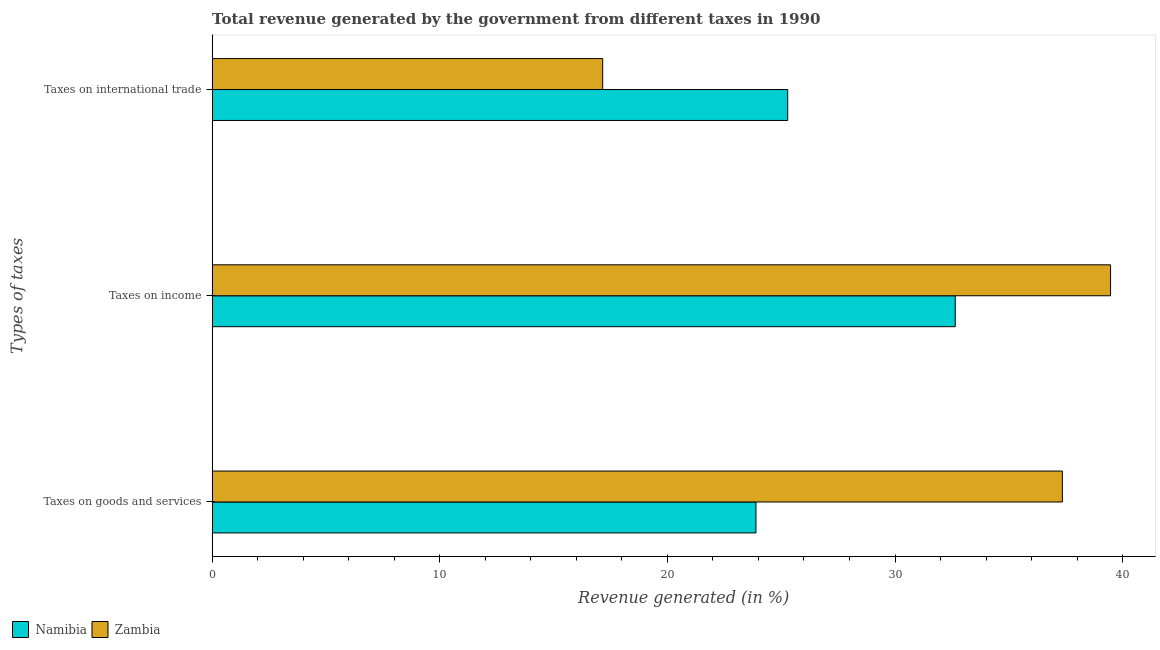How many different coloured bars are there?
Your answer should be compact. 2. What is the label of the 2nd group of bars from the top?
Give a very brief answer. Taxes on income. What is the percentage of revenue generated by tax on international trade in Zambia?
Offer a very short reply. 17.16. Across all countries, what is the maximum percentage of revenue generated by taxes on income?
Your answer should be very brief. 39.47. Across all countries, what is the minimum percentage of revenue generated by tax on international trade?
Provide a succinct answer. 17.16. In which country was the percentage of revenue generated by tax on international trade maximum?
Keep it short and to the point. Namibia. In which country was the percentage of revenue generated by taxes on income minimum?
Provide a short and direct response. Namibia. What is the total percentage of revenue generated by taxes on goods and services in the graph?
Make the answer very short. 61.24. What is the difference between the percentage of revenue generated by taxes on income in Zambia and that in Namibia?
Offer a very short reply. 6.82. What is the difference between the percentage of revenue generated by taxes on goods and services in Zambia and the percentage of revenue generated by taxes on income in Namibia?
Your answer should be compact. 4.71. What is the average percentage of revenue generated by taxes on goods and services per country?
Your answer should be compact. 30.62. What is the difference between the percentage of revenue generated by tax on international trade and percentage of revenue generated by taxes on income in Namibia?
Offer a very short reply. -7.36. In how many countries, is the percentage of revenue generated by tax on international trade greater than 20 %?
Provide a short and direct response. 1. What is the ratio of the percentage of revenue generated by tax on international trade in Namibia to that in Zambia?
Provide a short and direct response. 1.47. Is the percentage of revenue generated by tax on international trade in Zambia less than that in Namibia?
Ensure brevity in your answer.  Yes. Is the difference between the percentage of revenue generated by taxes on goods and services in Zambia and Namibia greater than the difference between the percentage of revenue generated by tax on international trade in Zambia and Namibia?
Provide a succinct answer. Yes. What is the difference between the highest and the second highest percentage of revenue generated by taxes on goods and services?
Provide a short and direct response. 13.46. What is the difference between the highest and the lowest percentage of revenue generated by tax on international trade?
Offer a terse response. 8.13. Is the sum of the percentage of revenue generated by taxes on goods and services in Namibia and Zambia greater than the maximum percentage of revenue generated by tax on international trade across all countries?
Give a very brief answer. Yes. What does the 1st bar from the top in Taxes on international trade represents?
Ensure brevity in your answer.  Zambia. What does the 2nd bar from the bottom in Taxes on goods and services represents?
Ensure brevity in your answer.  Zambia. How many bars are there?
Your answer should be compact. 6. How many countries are there in the graph?
Offer a terse response. 2. What is the difference between two consecutive major ticks on the X-axis?
Your response must be concise. 10. Does the graph contain grids?
Offer a terse response. No. Where does the legend appear in the graph?
Offer a terse response. Bottom left. How many legend labels are there?
Your answer should be compact. 2. How are the legend labels stacked?
Keep it short and to the point. Horizontal. What is the title of the graph?
Give a very brief answer. Total revenue generated by the government from different taxes in 1990. What is the label or title of the X-axis?
Offer a terse response. Revenue generated (in %). What is the label or title of the Y-axis?
Offer a terse response. Types of taxes. What is the Revenue generated (in %) of Namibia in Taxes on goods and services?
Keep it short and to the point. 23.89. What is the Revenue generated (in %) in Zambia in Taxes on goods and services?
Your response must be concise. 37.35. What is the Revenue generated (in %) of Namibia in Taxes on income?
Offer a terse response. 32.64. What is the Revenue generated (in %) in Zambia in Taxes on income?
Your answer should be very brief. 39.47. What is the Revenue generated (in %) of Namibia in Taxes on international trade?
Keep it short and to the point. 25.29. What is the Revenue generated (in %) in Zambia in Taxes on international trade?
Provide a succinct answer. 17.16. Across all Types of taxes, what is the maximum Revenue generated (in %) of Namibia?
Make the answer very short. 32.64. Across all Types of taxes, what is the maximum Revenue generated (in %) in Zambia?
Offer a very short reply. 39.47. Across all Types of taxes, what is the minimum Revenue generated (in %) in Namibia?
Your answer should be very brief. 23.89. Across all Types of taxes, what is the minimum Revenue generated (in %) of Zambia?
Provide a short and direct response. 17.16. What is the total Revenue generated (in %) in Namibia in the graph?
Your answer should be very brief. 81.82. What is the total Revenue generated (in %) of Zambia in the graph?
Make the answer very short. 93.98. What is the difference between the Revenue generated (in %) in Namibia in Taxes on goods and services and that in Taxes on income?
Offer a very short reply. -8.75. What is the difference between the Revenue generated (in %) of Zambia in Taxes on goods and services and that in Taxes on income?
Keep it short and to the point. -2.12. What is the difference between the Revenue generated (in %) in Namibia in Taxes on goods and services and that in Taxes on international trade?
Provide a succinct answer. -1.4. What is the difference between the Revenue generated (in %) of Zambia in Taxes on goods and services and that in Taxes on international trade?
Provide a short and direct response. 20.19. What is the difference between the Revenue generated (in %) of Namibia in Taxes on income and that in Taxes on international trade?
Ensure brevity in your answer.  7.36. What is the difference between the Revenue generated (in %) in Zambia in Taxes on income and that in Taxes on international trade?
Provide a succinct answer. 22.31. What is the difference between the Revenue generated (in %) of Namibia in Taxes on goods and services and the Revenue generated (in %) of Zambia in Taxes on income?
Provide a short and direct response. -15.58. What is the difference between the Revenue generated (in %) in Namibia in Taxes on goods and services and the Revenue generated (in %) in Zambia in Taxes on international trade?
Ensure brevity in your answer.  6.73. What is the difference between the Revenue generated (in %) of Namibia in Taxes on income and the Revenue generated (in %) of Zambia in Taxes on international trade?
Keep it short and to the point. 15.49. What is the average Revenue generated (in %) in Namibia per Types of taxes?
Your answer should be compact. 27.27. What is the average Revenue generated (in %) of Zambia per Types of taxes?
Give a very brief answer. 31.33. What is the difference between the Revenue generated (in %) of Namibia and Revenue generated (in %) of Zambia in Taxes on goods and services?
Provide a succinct answer. -13.46. What is the difference between the Revenue generated (in %) in Namibia and Revenue generated (in %) in Zambia in Taxes on income?
Make the answer very short. -6.82. What is the difference between the Revenue generated (in %) of Namibia and Revenue generated (in %) of Zambia in Taxes on international trade?
Your response must be concise. 8.13. What is the ratio of the Revenue generated (in %) in Namibia in Taxes on goods and services to that in Taxes on income?
Offer a very short reply. 0.73. What is the ratio of the Revenue generated (in %) in Zambia in Taxes on goods and services to that in Taxes on income?
Your answer should be very brief. 0.95. What is the ratio of the Revenue generated (in %) of Namibia in Taxes on goods and services to that in Taxes on international trade?
Provide a succinct answer. 0.94. What is the ratio of the Revenue generated (in %) in Zambia in Taxes on goods and services to that in Taxes on international trade?
Make the answer very short. 2.18. What is the ratio of the Revenue generated (in %) in Namibia in Taxes on income to that in Taxes on international trade?
Offer a very short reply. 1.29. What is the ratio of the Revenue generated (in %) in Zambia in Taxes on income to that in Taxes on international trade?
Offer a terse response. 2.3. What is the difference between the highest and the second highest Revenue generated (in %) in Namibia?
Provide a succinct answer. 7.36. What is the difference between the highest and the second highest Revenue generated (in %) in Zambia?
Give a very brief answer. 2.12. What is the difference between the highest and the lowest Revenue generated (in %) in Namibia?
Ensure brevity in your answer.  8.75. What is the difference between the highest and the lowest Revenue generated (in %) of Zambia?
Provide a short and direct response. 22.31. 